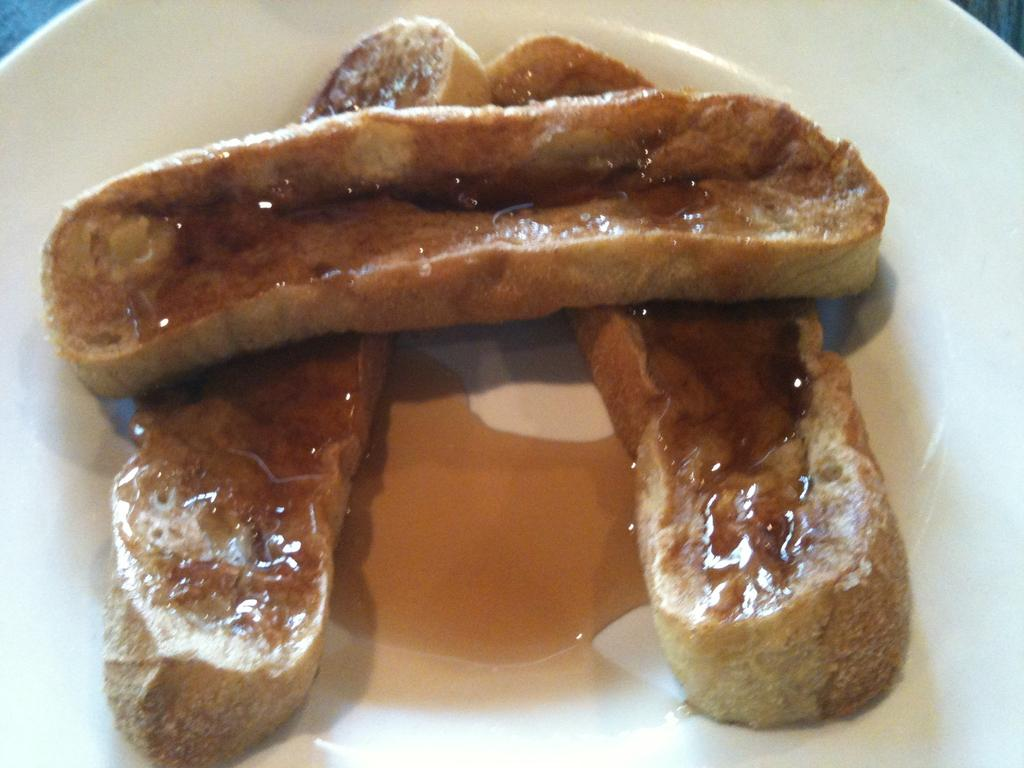What is on the plate that is visible in the image? The plate contains food. Where is the plate located in the image? The plate is on a surface. What type of paste is being used to stick the dolls together in the image? There are no dolls or paste present in the image; it only features a plate with food on a surface. 